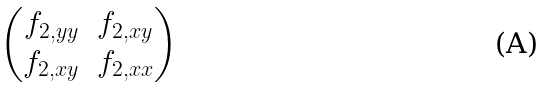<formula> <loc_0><loc_0><loc_500><loc_500>\begin{pmatrix} f _ { 2 , y y } & f _ { 2 , x y } \\ f _ { 2 , x y } & f _ { 2 , x x } \end{pmatrix}</formula> 